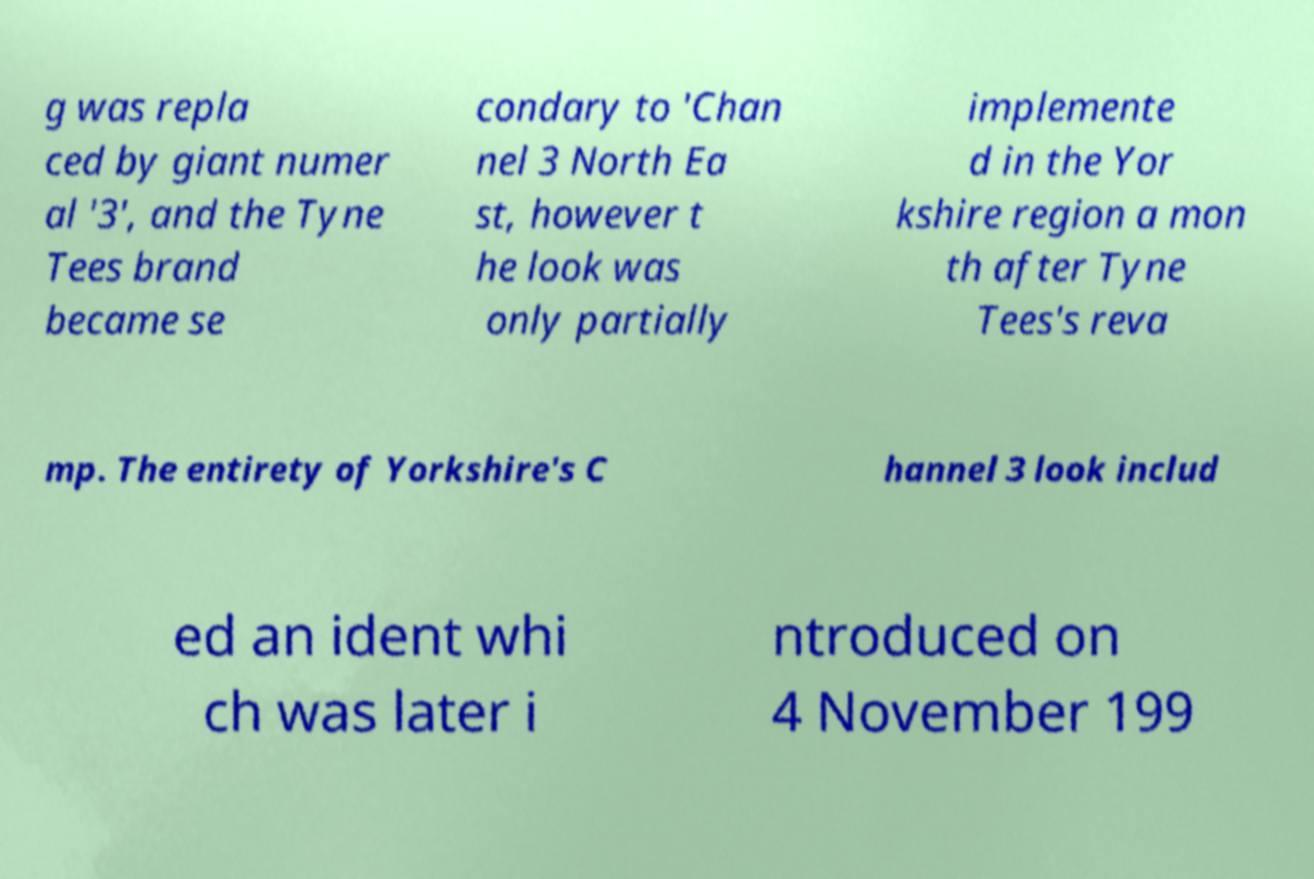There's text embedded in this image that I need extracted. Can you transcribe it verbatim? g was repla ced by giant numer al '3', and the Tyne Tees brand became se condary to 'Chan nel 3 North Ea st, however t he look was only partially implemente d in the Yor kshire region a mon th after Tyne Tees's reva mp. The entirety of Yorkshire's C hannel 3 look includ ed an ident whi ch was later i ntroduced on 4 November 199 